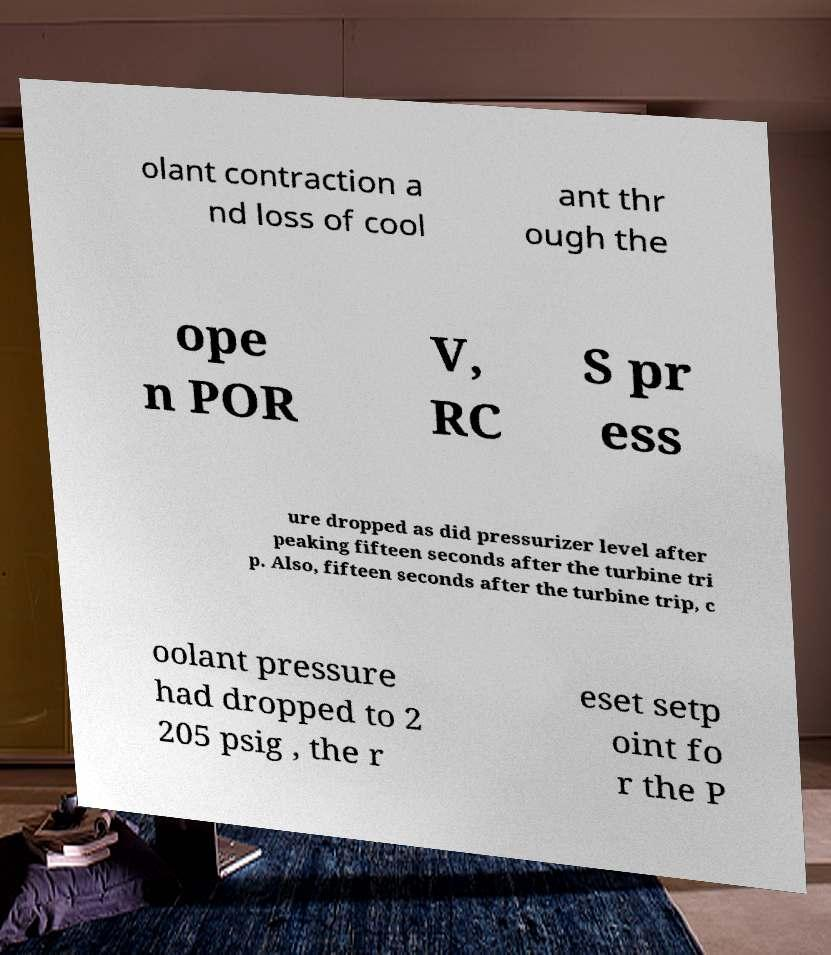Please read and relay the text visible in this image. What does it say? olant contraction a nd loss of cool ant thr ough the ope n POR V, RC S pr ess ure dropped as did pressurizer level after peaking fifteen seconds after the turbine tri p. Also, fifteen seconds after the turbine trip, c oolant pressure had dropped to 2 205 psig , the r eset setp oint fo r the P 